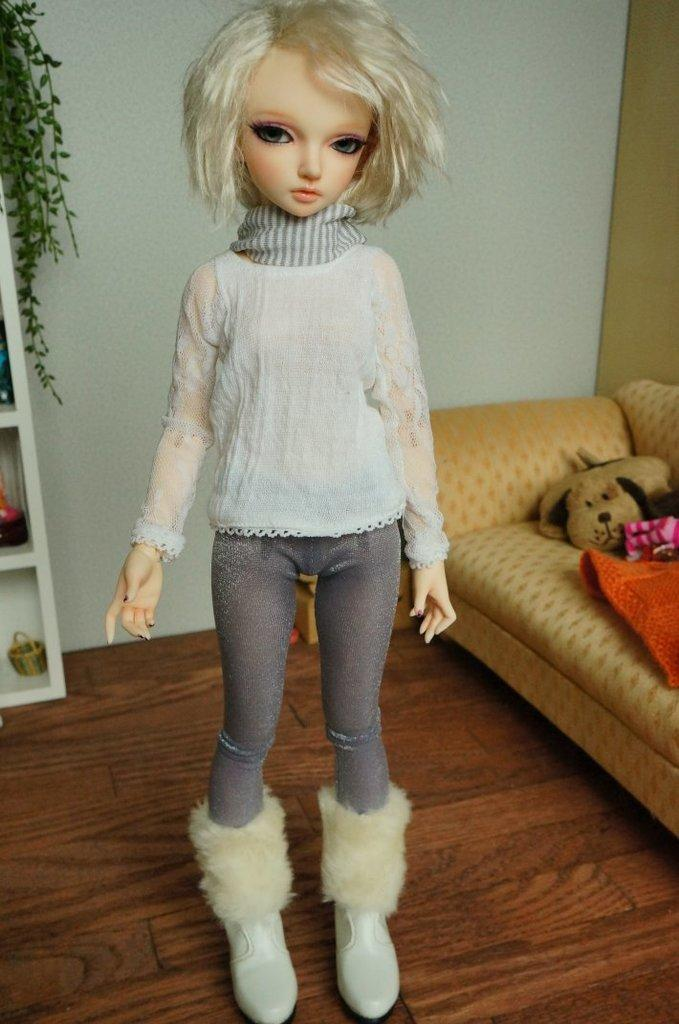What is the main subject in the image? There is a doll in the image. What else can be seen in the background of the image? There is a toy, clothes on the couch, objects in the racks, a wall, and a plant visible in the background. How many tomatoes are on the plant in the image? There are no tomatoes present in the image; only a plant is visible in the background. 